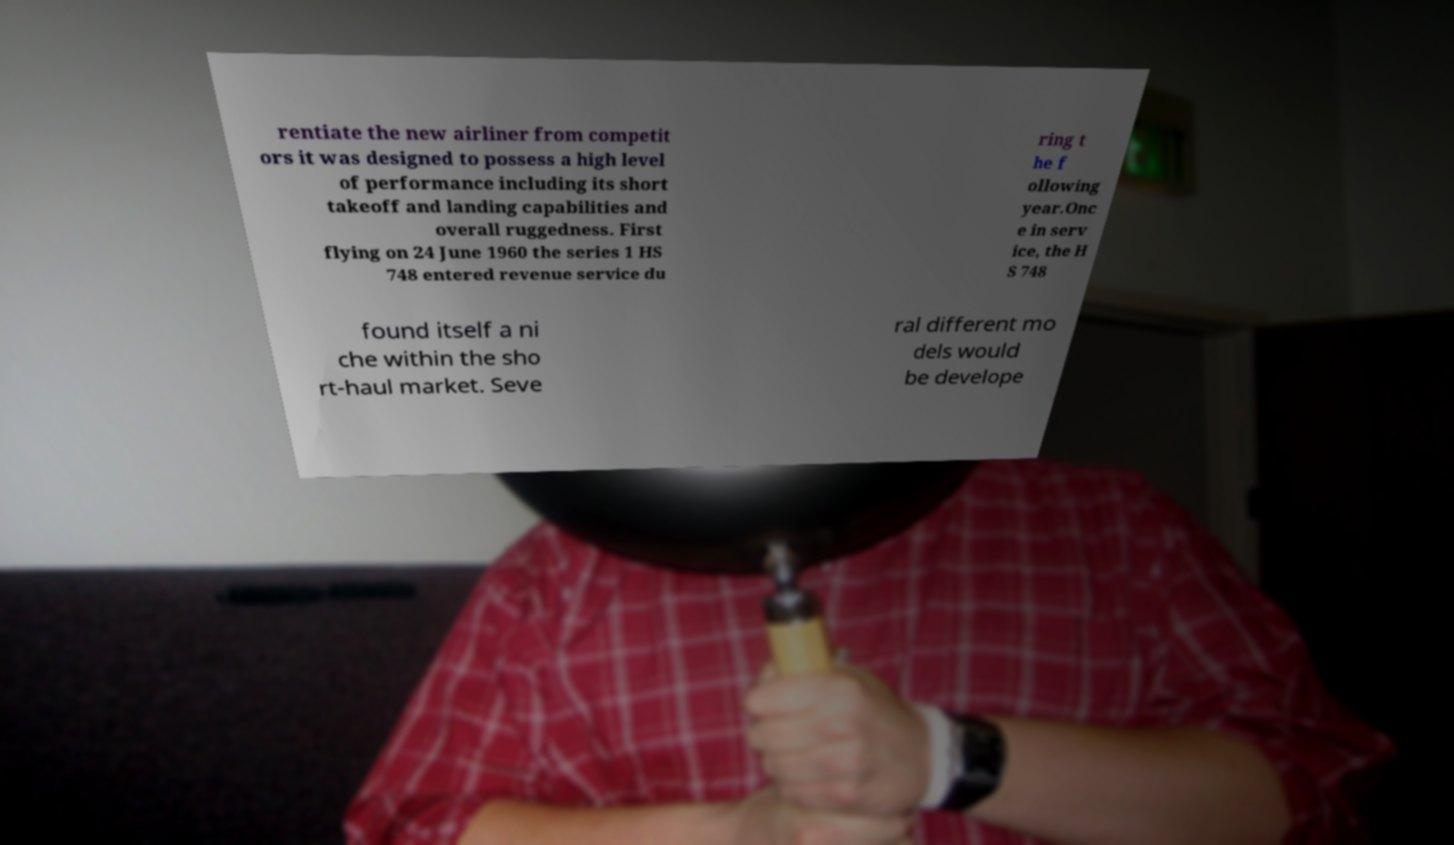There's text embedded in this image that I need extracted. Can you transcribe it verbatim? rentiate the new airliner from competit ors it was designed to possess a high level of performance including its short takeoff and landing capabilities and overall ruggedness. First flying on 24 June 1960 the series 1 HS 748 entered revenue service du ring t he f ollowing year.Onc e in serv ice, the H S 748 found itself a ni che within the sho rt-haul market. Seve ral different mo dels would be develope 